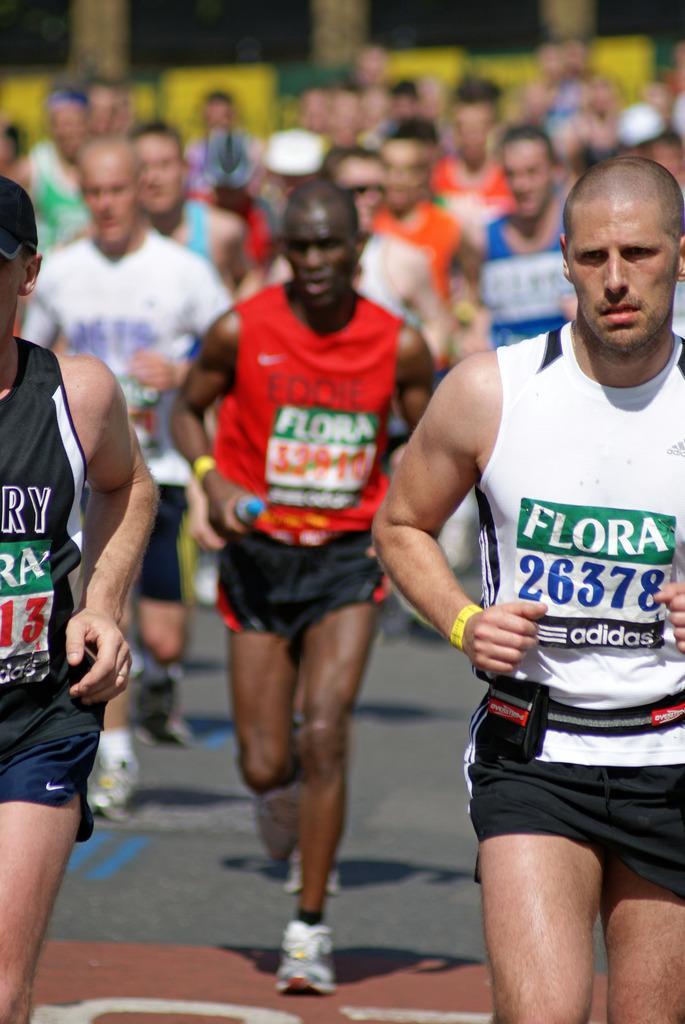<image>
Create a compact narrative representing the image presented. A group of runners all have race identification numbers with the word FLORA above them. 